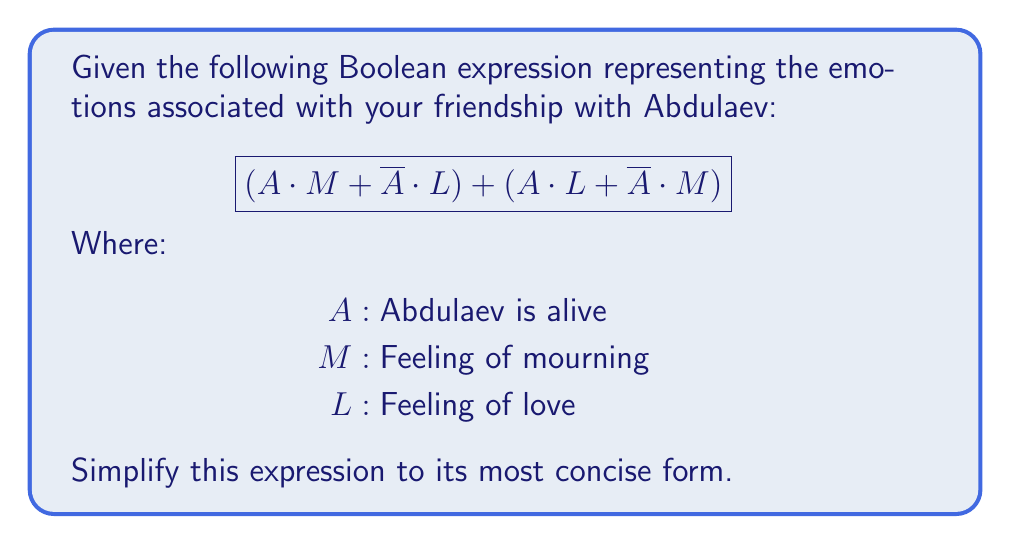Can you solve this math problem? Let's simplify this expression step by step:

1) First, let's distribute the terms:
   $$(A \cdot M + \overline{A} \cdot L) + (A \cdot L + \overline{A} \cdot M)$$

2) Now, we can rearrange the terms using the commutative property:
   $$(A \cdot M + A \cdot L) + (\overline{A} \cdot L + \overline{A} \cdot M)$$

3) We can factor out the common terms:
   $$A \cdot (M + L) + \overline{A} \cdot (L + M)$$

4) The terms $(M + L)$ and $(L + M)$ are identical due to the commutative property of addition in Boolean algebra. Let's call this term $X$:
   $$A \cdot X + \overline{A} \cdot X$$

5) Now we can factor out $X$:
   $$X \cdot (A + \overline{A})$$

6) In Boolean algebra, $A + \overline{A} = 1$ (this is known as the law of the excluded middle):
   $$X \cdot 1$$

7) Anything multiplied by 1 is itself, so our final expression is simply:
   $$X$$

8) Substituting back what $X$ represents:
   $$(M + L)$$

This simplified expression means that you are either feeling mourning or love (or both), regardless of whether Abdulaev is alive or not, which reflects the enduring nature of your friendship and emotions.
Answer: $M + L$ 